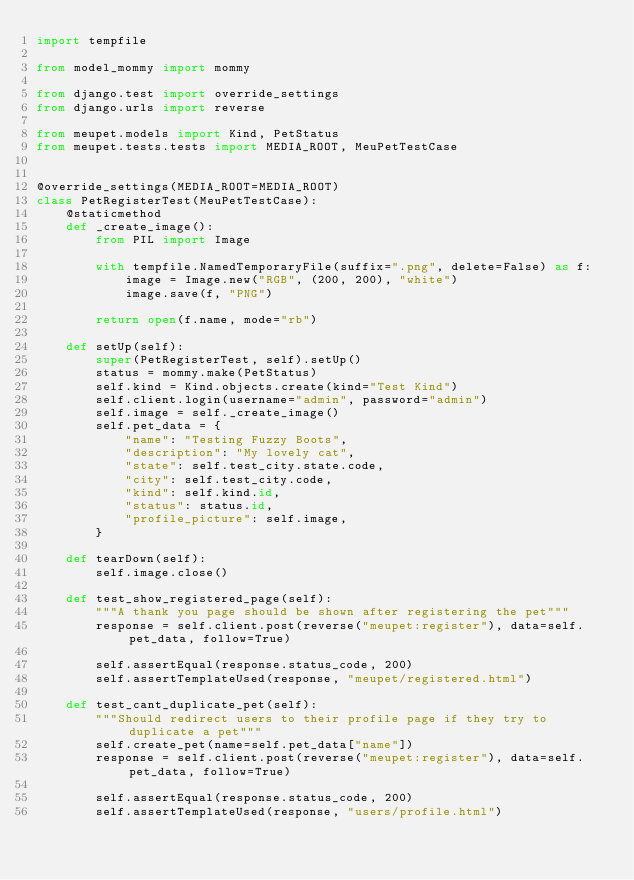Convert code to text. <code><loc_0><loc_0><loc_500><loc_500><_Python_>import tempfile

from model_mommy import mommy

from django.test import override_settings
from django.urls import reverse

from meupet.models import Kind, PetStatus
from meupet.tests.tests import MEDIA_ROOT, MeuPetTestCase


@override_settings(MEDIA_ROOT=MEDIA_ROOT)
class PetRegisterTest(MeuPetTestCase):
    @staticmethod
    def _create_image():
        from PIL import Image

        with tempfile.NamedTemporaryFile(suffix=".png", delete=False) as f:
            image = Image.new("RGB", (200, 200), "white")
            image.save(f, "PNG")

        return open(f.name, mode="rb")

    def setUp(self):
        super(PetRegisterTest, self).setUp()
        status = mommy.make(PetStatus)
        self.kind = Kind.objects.create(kind="Test Kind")
        self.client.login(username="admin", password="admin")
        self.image = self._create_image()
        self.pet_data = {
            "name": "Testing Fuzzy Boots",
            "description": "My lovely cat",
            "state": self.test_city.state.code,
            "city": self.test_city.code,
            "kind": self.kind.id,
            "status": status.id,
            "profile_picture": self.image,
        }

    def tearDown(self):
        self.image.close()

    def test_show_registered_page(self):
        """A thank you page should be shown after registering the pet"""
        response = self.client.post(reverse("meupet:register"), data=self.pet_data, follow=True)

        self.assertEqual(response.status_code, 200)
        self.assertTemplateUsed(response, "meupet/registered.html")

    def test_cant_duplicate_pet(self):
        """Should redirect users to their profile page if they try to duplicate a pet"""
        self.create_pet(name=self.pet_data["name"])
        response = self.client.post(reverse("meupet:register"), data=self.pet_data, follow=True)

        self.assertEqual(response.status_code, 200)
        self.assertTemplateUsed(response, "users/profile.html")
</code> 